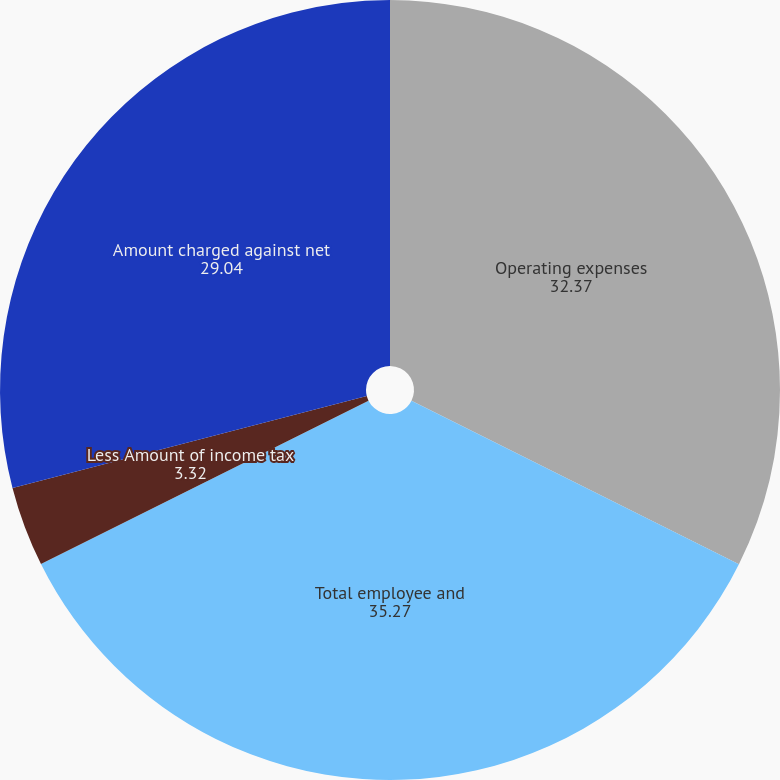<chart> <loc_0><loc_0><loc_500><loc_500><pie_chart><fcel>Operating expenses<fcel>Total employee and<fcel>Less Amount of income tax<fcel>Amount charged against net<nl><fcel>32.37%<fcel>35.27%<fcel>3.32%<fcel>29.04%<nl></chart> 